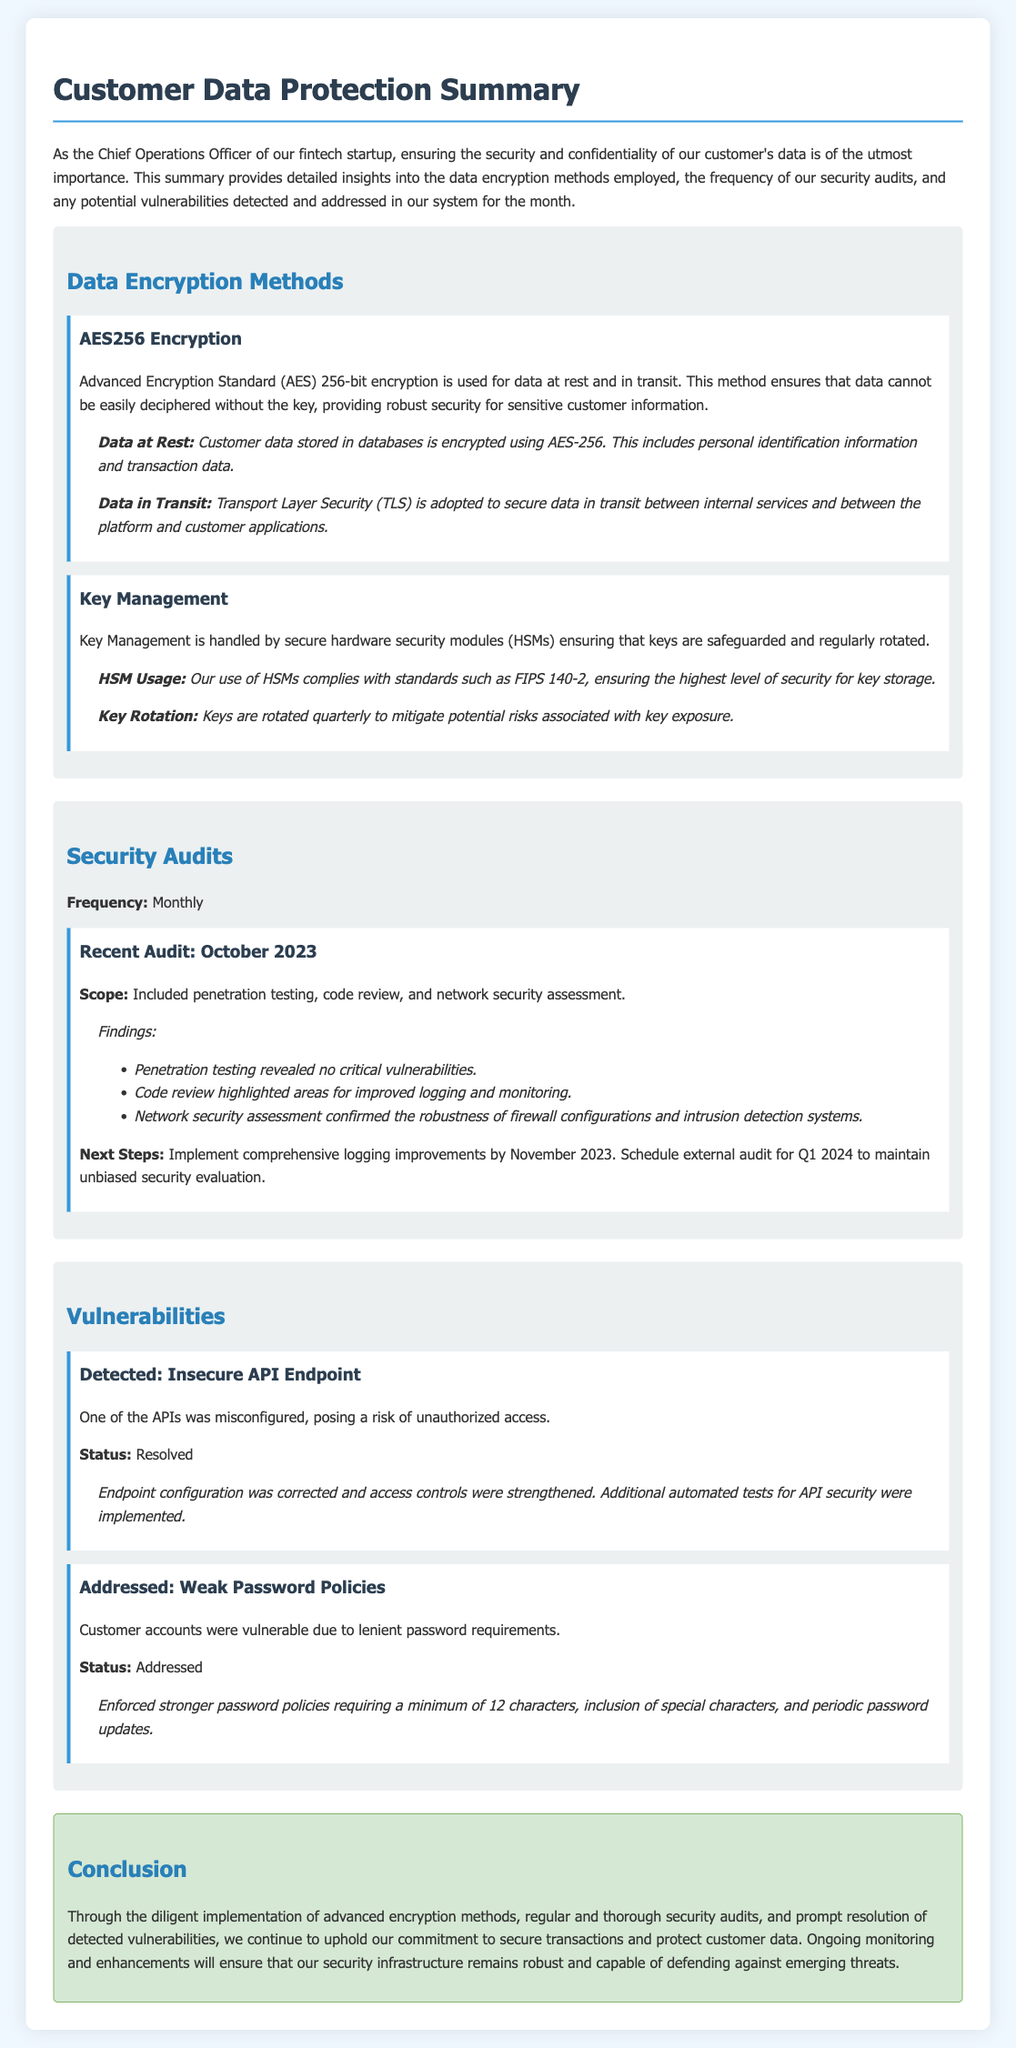What encryption method is used for data at rest? The document states that AES256 encryption is used for data at rest.
Answer: AES256 How often are security audits conducted? The document specifies that security audits are conducted monthly.
Answer: Monthly What was the recent audit month mentioned? The document indicates that the recent audit was conducted in October 2023.
Answer: October 2023 How many vulnerabilities were addressed in the document? The document mentions two vulnerabilities: insecure API endpoint and weak password policies.
Answer: Two What is the minimum password length enforced now? The document states that the new password policy requires a minimum of 12 characters.
Answer: 12 characters What was found during the penetration testing? The findings from the penetration testing indicated no critical vulnerabilities.
Answer: No critical vulnerabilities What is the status of the insecure API endpoint? The resolution indicates that the status of the insecure API endpoint is resolved.
Answer: Resolved When is the next external audit scheduled? The document mentions that the external audit is scheduled for Q1 2024.
Answer: Q1 2024 What security standard is referenced for HSMs? The document refers to the FIPS 140-2 standard for HSMs.
Answer: FIPS 140-2 